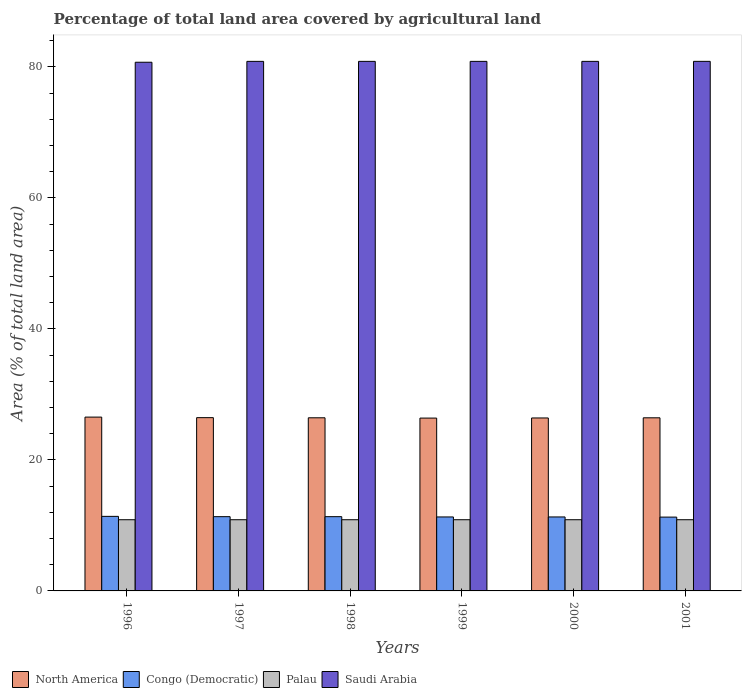How many different coloured bars are there?
Offer a very short reply. 4. How many groups of bars are there?
Provide a succinct answer. 6. How many bars are there on the 2nd tick from the left?
Provide a succinct answer. 4. What is the percentage of agricultural land in Palau in 2001?
Provide a short and direct response. 10.87. Across all years, what is the maximum percentage of agricultural land in Palau?
Give a very brief answer. 10.87. Across all years, what is the minimum percentage of agricultural land in Palau?
Your response must be concise. 10.87. In which year was the percentage of agricultural land in Palau maximum?
Your answer should be very brief. 1996. What is the total percentage of agricultural land in Palau in the graph?
Offer a terse response. 65.22. What is the difference between the percentage of agricultural land in Saudi Arabia in 1996 and that in 1999?
Offer a terse response. -0.13. What is the difference between the percentage of agricultural land in Palau in 2000 and the percentage of agricultural land in Saudi Arabia in 1997?
Provide a succinct answer. -69.97. What is the average percentage of agricultural land in Congo (Democratic) per year?
Offer a terse response. 11.32. In the year 1998, what is the difference between the percentage of agricultural land in Congo (Democratic) and percentage of agricultural land in Saudi Arabia?
Your answer should be very brief. -69.51. In how many years, is the percentage of agricultural land in Saudi Arabia greater than 76 %?
Offer a terse response. 6. What is the ratio of the percentage of agricultural land in Saudi Arabia in 1996 to that in 1999?
Ensure brevity in your answer.  1. What is the difference between the highest and the second highest percentage of agricultural land in Saudi Arabia?
Ensure brevity in your answer.  0. What is the difference between the highest and the lowest percentage of agricultural land in North America?
Offer a terse response. 0.15. In how many years, is the percentage of agricultural land in Congo (Democratic) greater than the average percentage of agricultural land in Congo (Democratic) taken over all years?
Offer a very short reply. 3. What does the 3rd bar from the left in 1999 represents?
Make the answer very short. Palau. What does the 4th bar from the right in 2001 represents?
Ensure brevity in your answer.  North America. How many bars are there?
Make the answer very short. 24. Are all the bars in the graph horizontal?
Keep it short and to the point. No. How many years are there in the graph?
Ensure brevity in your answer.  6. Does the graph contain any zero values?
Your response must be concise. No. What is the title of the graph?
Keep it short and to the point. Percentage of total land area covered by agricultural land. Does "Ukraine" appear as one of the legend labels in the graph?
Ensure brevity in your answer.  No. What is the label or title of the X-axis?
Your response must be concise. Years. What is the label or title of the Y-axis?
Your response must be concise. Area (% of total land area). What is the Area (% of total land area) of North America in 1996?
Ensure brevity in your answer.  26.54. What is the Area (% of total land area) in Congo (Democratic) in 1996?
Offer a very short reply. 11.38. What is the Area (% of total land area) in Palau in 1996?
Keep it short and to the point. 10.87. What is the Area (% of total land area) in Saudi Arabia in 1996?
Your answer should be very brief. 80.71. What is the Area (% of total land area) of North America in 1997?
Provide a succinct answer. 26.45. What is the Area (% of total land area) of Congo (Democratic) in 1997?
Your response must be concise. 11.34. What is the Area (% of total land area) of Palau in 1997?
Offer a very short reply. 10.87. What is the Area (% of total land area) of Saudi Arabia in 1997?
Ensure brevity in your answer.  80.84. What is the Area (% of total land area) of North America in 1998?
Keep it short and to the point. 26.43. What is the Area (% of total land area) in Congo (Democratic) in 1998?
Give a very brief answer. 11.34. What is the Area (% of total land area) in Palau in 1998?
Ensure brevity in your answer.  10.87. What is the Area (% of total land area) in Saudi Arabia in 1998?
Your response must be concise. 80.84. What is the Area (% of total land area) of North America in 1999?
Your response must be concise. 26.39. What is the Area (% of total land area) of Congo (Democratic) in 1999?
Give a very brief answer. 11.29. What is the Area (% of total land area) in Palau in 1999?
Ensure brevity in your answer.  10.87. What is the Area (% of total land area) in Saudi Arabia in 1999?
Your response must be concise. 80.84. What is the Area (% of total land area) in North America in 2000?
Provide a succinct answer. 26.4. What is the Area (% of total land area) of Congo (Democratic) in 2000?
Your answer should be compact. 11.29. What is the Area (% of total land area) in Palau in 2000?
Offer a terse response. 10.87. What is the Area (% of total land area) of Saudi Arabia in 2000?
Offer a very short reply. 80.84. What is the Area (% of total land area) in North America in 2001?
Your answer should be very brief. 26.43. What is the Area (% of total land area) of Congo (Democratic) in 2001?
Ensure brevity in your answer.  11.27. What is the Area (% of total land area) in Palau in 2001?
Offer a very short reply. 10.87. What is the Area (% of total land area) of Saudi Arabia in 2001?
Give a very brief answer. 80.84. Across all years, what is the maximum Area (% of total land area) of North America?
Give a very brief answer. 26.54. Across all years, what is the maximum Area (% of total land area) in Congo (Democratic)?
Give a very brief answer. 11.38. Across all years, what is the maximum Area (% of total land area) in Palau?
Make the answer very short. 10.87. Across all years, what is the maximum Area (% of total land area) of Saudi Arabia?
Give a very brief answer. 80.84. Across all years, what is the minimum Area (% of total land area) of North America?
Make the answer very short. 26.39. Across all years, what is the minimum Area (% of total land area) of Congo (Democratic)?
Make the answer very short. 11.27. Across all years, what is the minimum Area (% of total land area) of Palau?
Your answer should be compact. 10.87. Across all years, what is the minimum Area (% of total land area) in Saudi Arabia?
Your response must be concise. 80.71. What is the total Area (% of total land area) of North America in the graph?
Give a very brief answer. 158.64. What is the total Area (% of total land area) in Congo (Democratic) in the graph?
Ensure brevity in your answer.  67.91. What is the total Area (% of total land area) of Palau in the graph?
Provide a short and direct response. 65.22. What is the total Area (% of total land area) in Saudi Arabia in the graph?
Make the answer very short. 484.92. What is the difference between the Area (% of total land area) in North America in 1996 and that in 1997?
Provide a short and direct response. 0.08. What is the difference between the Area (% of total land area) of Congo (Democratic) in 1996 and that in 1997?
Offer a terse response. 0.04. What is the difference between the Area (% of total land area) in Saudi Arabia in 1996 and that in 1997?
Give a very brief answer. -0.13. What is the difference between the Area (% of total land area) of North America in 1996 and that in 1998?
Your answer should be very brief. 0.11. What is the difference between the Area (% of total land area) of Congo (Democratic) in 1996 and that in 1998?
Offer a terse response. 0.04. What is the difference between the Area (% of total land area) in Saudi Arabia in 1996 and that in 1998?
Ensure brevity in your answer.  -0.13. What is the difference between the Area (% of total land area) of North America in 1996 and that in 1999?
Your answer should be very brief. 0.15. What is the difference between the Area (% of total land area) in Congo (Democratic) in 1996 and that in 1999?
Make the answer very short. 0.09. What is the difference between the Area (% of total land area) of Palau in 1996 and that in 1999?
Make the answer very short. 0. What is the difference between the Area (% of total land area) of Saudi Arabia in 1996 and that in 1999?
Make the answer very short. -0.13. What is the difference between the Area (% of total land area) in North America in 1996 and that in 2000?
Offer a terse response. 0.13. What is the difference between the Area (% of total land area) in Congo (Democratic) in 1996 and that in 2000?
Your response must be concise. 0.09. What is the difference between the Area (% of total land area) of Palau in 1996 and that in 2000?
Your answer should be compact. 0. What is the difference between the Area (% of total land area) in Saudi Arabia in 1996 and that in 2000?
Provide a succinct answer. -0.13. What is the difference between the Area (% of total land area) in North America in 1996 and that in 2001?
Offer a terse response. 0.11. What is the difference between the Area (% of total land area) of Congo (Democratic) in 1996 and that in 2001?
Ensure brevity in your answer.  0.11. What is the difference between the Area (% of total land area) of Palau in 1996 and that in 2001?
Your response must be concise. 0. What is the difference between the Area (% of total land area) in Saudi Arabia in 1996 and that in 2001?
Your answer should be very brief. -0.14. What is the difference between the Area (% of total land area) of North America in 1997 and that in 1998?
Ensure brevity in your answer.  0.02. What is the difference between the Area (% of total land area) in North America in 1997 and that in 1999?
Offer a very short reply. 0.07. What is the difference between the Area (% of total land area) of Congo (Democratic) in 1997 and that in 1999?
Offer a very short reply. 0.04. What is the difference between the Area (% of total land area) of Palau in 1997 and that in 1999?
Provide a short and direct response. 0. What is the difference between the Area (% of total land area) of North America in 1997 and that in 2000?
Provide a succinct answer. 0.05. What is the difference between the Area (% of total land area) in Congo (Democratic) in 1997 and that in 2000?
Your response must be concise. 0.04. What is the difference between the Area (% of total land area) of Saudi Arabia in 1997 and that in 2000?
Your answer should be compact. 0. What is the difference between the Area (% of total land area) of North America in 1997 and that in 2001?
Your answer should be very brief. 0.03. What is the difference between the Area (% of total land area) of Congo (Democratic) in 1997 and that in 2001?
Your answer should be compact. 0.07. What is the difference between the Area (% of total land area) in Palau in 1997 and that in 2001?
Offer a very short reply. 0. What is the difference between the Area (% of total land area) in Saudi Arabia in 1997 and that in 2001?
Your response must be concise. -0. What is the difference between the Area (% of total land area) in North America in 1998 and that in 1999?
Your answer should be compact. 0.04. What is the difference between the Area (% of total land area) in Congo (Democratic) in 1998 and that in 1999?
Your answer should be very brief. 0.04. What is the difference between the Area (% of total land area) in Palau in 1998 and that in 1999?
Give a very brief answer. 0. What is the difference between the Area (% of total land area) of Saudi Arabia in 1998 and that in 1999?
Offer a very short reply. 0. What is the difference between the Area (% of total land area) in North America in 1998 and that in 2000?
Provide a succinct answer. 0.03. What is the difference between the Area (% of total land area) of Congo (Democratic) in 1998 and that in 2000?
Keep it short and to the point. 0.04. What is the difference between the Area (% of total land area) in Saudi Arabia in 1998 and that in 2000?
Give a very brief answer. 0. What is the difference between the Area (% of total land area) of North America in 1998 and that in 2001?
Ensure brevity in your answer.  0. What is the difference between the Area (% of total land area) of Congo (Democratic) in 1998 and that in 2001?
Provide a succinct answer. 0.07. What is the difference between the Area (% of total land area) in Saudi Arabia in 1998 and that in 2001?
Offer a very short reply. -0. What is the difference between the Area (% of total land area) in North America in 1999 and that in 2000?
Your answer should be very brief. -0.02. What is the difference between the Area (% of total land area) in Saudi Arabia in 1999 and that in 2000?
Offer a very short reply. 0. What is the difference between the Area (% of total land area) in North America in 1999 and that in 2001?
Give a very brief answer. -0.04. What is the difference between the Area (% of total land area) of Congo (Democratic) in 1999 and that in 2001?
Offer a very short reply. 0.02. What is the difference between the Area (% of total land area) in Saudi Arabia in 1999 and that in 2001?
Your answer should be compact. -0. What is the difference between the Area (% of total land area) in North America in 2000 and that in 2001?
Ensure brevity in your answer.  -0.02. What is the difference between the Area (% of total land area) of Congo (Democratic) in 2000 and that in 2001?
Ensure brevity in your answer.  0.02. What is the difference between the Area (% of total land area) of Palau in 2000 and that in 2001?
Make the answer very short. 0. What is the difference between the Area (% of total land area) of Saudi Arabia in 2000 and that in 2001?
Offer a terse response. -0. What is the difference between the Area (% of total land area) of North America in 1996 and the Area (% of total land area) of Congo (Democratic) in 1997?
Provide a succinct answer. 15.2. What is the difference between the Area (% of total land area) of North America in 1996 and the Area (% of total land area) of Palau in 1997?
Provide a succinct answer. 15.67. What is the difference between the Area (% of total land area) in North America in 1996 and the Area (% of total land area) in Saudi Arabia in 1997?
Keep it short and to the point. -54.31. What is the difference between the Area (% of total land area) of Congo (Democratic) in 1996 and the Area (% of total land area) of Palau in 1997?
Your answer should be very brief. 0.51. What is the difference between the Area (% of total land area) in Congo (Democratic) in 1996 and the Area (% of total land area) in Saudi Arabia in 1997?
Provide a succinct answer. -69.46. What is the difference between the Area (% of total land area) in Palau in 1996 and the Area (% of total land area) in Saudi Arabia in 1997?
Offer a very short reply. -69.97. What is the difference between the Area (% of total land area) of North America in 1996 and the Area (% of total land area) of Congo (Democratic) in 1998?
Ensure brevity in your answer.  15.2. What is the difference between the Area (% of total land area) of North America in 1996 and the Area (% of total land area) of Palau in 1998?
Make the answer very short. 15.67. What is the difference between the Area (% of total land area) of North America in 1996 and the Area (% of total land area) of Saudi Arabia in 1998?
Give a very brief answer. -54.31. What is the difference between the Area (% of total land area) in Congo (Democratic) in 1996 and the Area (% of total land area) in Palau in 1998?
Keep it short and to the point. 0.51. What is the difference between the Area (% of total land area) in Congo (Democratic) in 1996 and the Area (% of total land area) in Saudi Arabia in 1998?
Ensure brevity in your answer.  -69.46. What is the difference between the Area (% of total land area) in Palau in 1996 and the Area (% of total land area) in Saudi Arabia in 1998?
Keep it short and to the point. -69.97. What is the difference between the Area (% of total land area) of North America in 1996 and the Area (% of total land area) of Congo (Democratic) in 1999?
Give a very brief answer. 15.24. What is the difference between the Area (% of total land area) of North America in 1996 and the Area (% of total land area) of Palau in 1999?
Your response must be concise. 15.67. What is the difference between the Area (% of total land area) of North America in 1996 and the Area (% of total land area) of Saudi Arabia in 1999?
Ensure brevity in your answer.  -54.31. What is the difference between the Area (% of total land area) of Congo (Democratic) in 1996 and the Area (% of total land area) of Palau in 1999?
Offer a terse response. 0.51. What is the difference between the Area (% of total land area) in Congo (Democratic) in 1996 and the Area (% of total land area) in Saudi Arabia in 1999?
Your answer should be very brief. -69.46. What is the difference between the Area (% of total land area) of Palau in 1996 and the Area (% of total land area) of Saudi Arabia in 1999?
Offer a terse response. -69.97. What is the difference between the Area (% of total land area) in North America in 1996 and the Area (% of total land area) in Congo (Democratic) in 2000?
Give a very brief answer. 15.24. What is the difference between the Area (% of total land area) in North America in 1996 and the Area (% of total land area) in Palau in 2000?
Offer a terse response. 15.67. What is the difference between the Area (% of total land area) in North America in 1996 and the Area (% of total land area) in Saudi Arabia in 2000?
Your answer should be very brief. -54.31. What is the difference between the Area (% of total land area) of Congo (Democratic) in 1996 and the Area (% of total land area) of Palau in 2000?
Offer a very short reply. 0.51. What is the difference between the Area (% of total land area) in Congo (Democratic) in 1996 and the Area (% of total land area) in Saudi Arabia in 2000?
Offer a terse response. -69.46. What is the difference between the Area (% of total land area) in Palau in 1996 and the Area (% of total land area) in Saudi Arabia in 2000?
Keep it short and to the point. -69.97. What is the difference between the Area (% of total land area) in North America in 1996 and the Area (% of total land area) in Congo (Democratic) in 2001?
Offer a terse response. 15.27. What is the difference between the Area (% of total land area) in North America in 1996 and the Area (% of total land area) in Palau in 2001?
Ensure brevity in your answer.  15.67. What is the difference between the Area (% of total land area) of North America in 1996 and the Area (% of total land area) of Saudi Arabia in 2001?
Offer a terse response. -54.31. What is the difference between the Area (% of total land area) in Congo (Democratic) in 1996 and the Area (% of total land area) in Palau in 2001?
Provide a short and direct response. 0.51. What is the difference between the Area (% of total land area) of Congo (Democratic) in 1996 and the Area (% of total land area) of Saudi Arabia in 2001?
Provide a succinct answer. -69.46. What is the difference between the Area (% of total land area) of Palau in 1996 and the Area (% of total land area) of Saudi Arabia in 2001?
Provide a succinct answer. -69.98. What is the difference between the Area (% of total land area) in North America in 1997 and the Area (% of total land area) in Congo (Democratic) in 1998?
Keep it short and to the point. 15.12. What is the difference between the Area (% of total land area) in North America in 1997 and the Area (% of total land area) in Palau in 1998?
Offer a very short reply. 15.58. What is the difference between the Area (% of total land area) in North America in 1997 and the Area (% of total land area) in Saudi Arabia in 1998?
Your answer should be very brief. -54.39. What is the difference between the Area (% of total land area) of Congo (Democratic) in 1997 and the Area (% of total land area) of Palau in 1998?
Offer a very short reply. 0.47. What is the difference between the Area (% of total land area) of Congo (Democratic) in 1997 and the Area (% of total land area) of Saudi Arabia in 1998?
Your response must be concise. -69.51. What is the difference between the Area (% of total land area) in Palau in 1997 and the Area (% of total land area) in Saudi Arabia in 1998?
Provide a succinct answer. -69.97. What is the difference between the Area (% of total land area) in North America in 1997 and the Area (% of total land area) in Congo (Democratic) in 1999?
Provide a short and direct response. 15.16. What is the difference between the Area (% of total land area) of North America in 1997 and the Area (% of total land area) of Palau in 1999?
Provide a succinct answer. 15.58. What is the difference between the Area (% of total land area) in North America in 1997 and the Area (% of total land area) in Saudi Arabia in 1999?
Give a very brief answer. -54.39. What is the difference between the Area (% of total land area) in Congo (Democratic) in 1997 and the Area (% of total land area) in Palau in 1999?
Provide a short and direct response. 0.47. What is the difference between the Area (% of total land area) of Congo (Democratic) in 1997 and the Area (% of total land area) of Saudi Arabia in 1999?
Offer a terse response. -69.51. What is the difference between the Area (% of total land area) of Palau in 1997 and the Area (% of total land area) of Saudi Arabia in 1999?
Make the answer very short. -69.97. What is the difference between the Area (% of total land area) in North America in 1997 and the Area (% of total land area) in Congo (Democratic) in 2000?
Make the answer very short. 15.16. What is the difference between the Area (% of total land area) of North America in 1997 and the Area (% of total land area) of Palau in 2000?
Give a very brief answer. 15.58. What is the difference between the Area (% of total land area) in North America in 1997 and the Area (% of total land area) in Saudi Arabia in 2000?
Keep it short and to the point. -54.39. What is the difference between the Area (% of total land area) of Congo (Democratic) in 1997 and the Area (% of total land area) of Palau in 2000?
Make the answer very short. 0.47. What is the difference between the Area (% of total land area) in Congo (Democratic) in 1997 and the Area (% of total land area) in Saudi Arabia in 2000?
Give a very brief answer. -69.51. What is the difference between the Area (% of total land area) in Palau in 1997 and the Area (% of total land area) in Saudi Arabia in 2000?
Provide a short and direct response. -69.97. What is the difference between the Area (% of total land area) in North America in 1997 and the Area (% of total land area) in Congo (Democratic) in 2001?
Offer a terse response. 15.18. What is the difference between the Area (% of total land area) in North America in 1997 and the Area (% of total land area) in Palau in 2001?
Ensure brevity in your answer.  15.58. What is the difference between the Area (% of total land area) of North America in 1997 and the Area (% of total land area) of Saudi Arabia in 2001?
Offer a terse response. -54.39. What is the difference between the Area (% of total land area) of Congo (Democratic) in 1997 and the Area (% of total land area) of Palau in 2001?
Make the answer very short. 0.47. What is the difference between the Area (% of total land area) in Congo (Democratic) in 1997 and the Area (% of total land area) in Saudi Arabia in 2001?
Give a very brief answer. -69.51. What is the difference between the Area (% of total land area) in Palau in 1997 and the Area (% of total land area) in Saudi Arabia in 2001?
Your answer should be compact. -69.98. What is the difference between the Area (% of total land area) of North America in 1998 and the Area (% of total land area) of Congo (Democratic) in 1999?
Your answer should be very brief. 15.14. What is the difference between the Area (% of total land area) of North America in 1998 and the Area (% of total land area) of Palau in 1999?
Provide a succinct answer. 15.56. What is the difference between the Area (% of total land area) in North America in 1998 and the Area (% of total land area) in Saudi Arabia in 1999?
Your answer should be compact. -54.41. What is the difference between the Area (% of total land area) in Congo (Democratic) in 1998 and the Area (% of total land area) in Palau in 1999?
Keep it short and to the point. 0.47. What is the difference between the Area (% of total land area) in Congo (Democratic) in 1998 and the Area (% of total land area) in Saudi Arabia in 1999?
Give a very brief answer. -69.51. What is the difference between the Area (% of total land area) of Palau in 1998 and the Area (% of total land area) of Saudi Arabia in 1999?
Provide a succinct answer. -69.97. What is the difference between the Area (% of total land area) of North America in 1998 and the Area (% of total land area) of Congo (Democratic) in 2000?
Your answer should be very brief. 15.14. What is the difference between the Area (% of total land area) of North America in 1998 and the Area (% of total land area) of Palau in 2000?
Offer a very short reply. 15.56. What is the difference between the Area (% of total land area) of North America in 1998 and the Area (% of total land area) of Saudi Arabia in 2000?
Keep it short and to the point. -54.41. What is the difference between the Area (% of total land area) of Congo (Democratic) in 1998 and the Area (% of total land area) of Palau in 2000?
Provide a short and direct response. 0.47. What is the difference between the Area (% of total land area) of Congo (Democratic) in 1998 and the Area (% of total land area) of Saudi Arabia in 2000?
Offer a terse response. -69.51. What is the difference between the Area (% of total land area) in Palau in 1998 and the Area (% of total land area) in Saudi Arabia in 2000?
Ensure brevity in your answer.  -69.97. What is the difference between the Area (% of total land area) in North America in 1998 and the Area (% of total land area) in Congo (Democratic) in 2001?
Keep it short and to the point. 15.16. What is the difference between the Area (% of total land area) of North America in 1998 and the Area (% of total land area) of Palau in 2001?
Ensure brevity in your answer.  15.56. What is the difference between the Area (% of total land area) of North America in 1998 and the Area (% of total land area) of Saudi Arabia in 2001?
Give a very brief answer. -54.41. What is the difference between the Area (% of total land area) of Congo (Democratic) in 1998 and the Area (% of total land area) of Palau in 2001?
Make the answer very short. 0.47. What is the difference between the Area (% of total land area) in Congo (Democratic) in 1998 and the Area (% of total land area) in Saudi Arabia in 2001?
Your answer should be compact. -69.51. What is the difference between the Area (% of total land area) in Palau in 1998 and the Area (% of total land area) in Saudi Arabia in 2001?
Make the answer very short. -69.98. What is the difference between the Area (% of total land area) of North America in 1999 and the Area (% of total land area) of Congo (Democratic) in 2000?
Give a very brief answer. 15.09. What is the difference between the Area (% of total land area) in North America in 1999 and the Area (% of total land area) in Palau in 2000?
Keep it short and to the point. 15.52. What is the difference between the Area (% of total land area) of North America in 1999 and the Area (% of total land area) of Saudi Arabia in 2000?
Make the answer very short. -54.46. What is the difference between the Area (% of total land area) in Congo (Democratic) in 1999 and the Area (% of total land area) in Palau in 2000?
Offer a terse response. 0.42. What is the difference between the Area (% of total land area) of Congo (Democratic) in 1999 and the Area (% of total land area) of Saudi Arabia in 2000?
Offer a very short reply. -69.55. What is the difference between the Area (% of total land area) of Palau in 1999 and the Area (% of total land area) of Saudi Arabia in 2000?
Your answer should be compact. -69.97. What is the difference between the Area (% of total land area) of North America in 1999 and the Area (% of total land area) of Congo (Democratic) in 2001?
Keep it short and to the point. 15.12. What is the difference between the Area (% of total land area) of North America in 1999 and the Area (% of total land area) of Palau in 2001?
Your answer should be very brief. 15.52. What is the difference between the Area (% of total land area) in North America in 1999 and the Area (% of total land area) in Saudi Arabia in 2001?
Ensure brevity in your answer.  -54.46. What is the difference between the Area (% of total land area) in Congo (Democratic) in 1999 and the Area (% of total land area) in Palau in 2001?
Provide a succinct answer. 0.42. What is the difference between the Area (% of total land area) of Congo (Democratic) in 1999 and the Area (% of total land area) of Saudi Arabia in 2001?
Provide a short and direct response. -69.55. What is the difference between the Area (% of total land area) of Palau in 1999 and the Area (% of total land area) of Saudi Arabia in 2001?
Ensure brevity in your answer.  -69.98. What is the difference between the Area (% of total land area) of North America in 2000 and the Area (% of total land area) of Congo (Democratic) in 2001?
Your response must be concise. 15.13. What is the difference between the Area (% of total land area) in North America in 2000 and the Area (% of total land area) in Palau in 2001?
Keep it short and to the point. 15.53. What is the difference between the Area (% of total land area) in North America in 2000 and the Area (% of total land area) in Saudi Arabia in 2001?
Provide a short and direct response. -54.44. What is the difference between the Area (% of total land area) in Congo (Democratic) in 2000 and the Area (% of total land area) in Palau in 2001?
Offer a terse response. 0.42. What is the difference between the Area (% of total land area) in Congo (Democratic) in 2000 and the Area (% of total land area) in Saudi Arabia in 2001?
Offer a very short reply. -69.55. What is the difference between the Area (% of total land area) in Palau in 2000 and the Area (% of total land area) in Saudi Arabia in 2001?
Ensure brevity in your answer.  -69.98. What is the average Area (% of total land area) of North America per year?
Make the answer very short. 26.44. What is the average Area (% of total land area) of Congo (Democratic) per year?
Offer a terse response. 11.32. What is the average Area (% of total land area) of Palau per year?
Your response must be concise. 10.87. What is the average Area (% of total land area) in Saudi Arabia per year?
Provide a short and direct response. 80.82. In the year 1996, what is the difference between the Area (% of total land area) of North America and Area (% of total land area) of Congo (Democratic)?
Your answer should be compact. 15.16. In the year 1996, what is the difference between the Area (% of total land area) of North America and Area (% of total land area) of Palau?
Ensure brevity in your answer.  15.67. In the year 1996, what is the difference between the Area (% of total land area) of North America and Area (% of total land area) of Saudi Arabia?
Provide a short and direct response. -54.17. In the year 1996, what is the difference between the Area (% of total land area) in Congo (Democratic) and Area (% of total land area) in Palau?
Make the answer very short. 0.51. In the year 1996, what is the difference between the Area (% of total land area) in Congo (Democratic) and Area (% of total land area) in Saudi Arabia?
Provide a succinct answer. -69.33. In the year 1996, what is the difference between the Area (% of total land area) of Palau and Area (% of total land area) of Saudi Arabia?
Offer a very short reply. -69.84. In the year 1997, what is the difference between the Area (% of total land area) in North America and Area (% of total land area) in Congo (Democratic)?
Give a very brief answer. 15.12. In the year 1997, what is the difference between the Area (% of total land area) in North America and Area (% of total land area) in Palau?
Offer a terse response. 15.58. In the year 1997, what is the difference between the Area (% of total land area) in North America and Area (% of total land area) in Saudi Arabia?
Offer a very short reply. -54.39. In the year 1997, what is the difference between the Area (% of total land area) in Congo (Democratic) and Area (% of total land area) in Palau?
Make the answer very short. 0.47. In the year 1997, what is the difference between the Area (% of total land area) in Congo (Democratic) and Area (% of total land area) in Saudi Arabia?
Your answer should be compact. -69.51. In the year 1997, what is the difference between the Area (% of total land area) of Palau and Area (% of total land area) of Saudi Arabia?
Give a very brief answer. -69.97. In the year 1998, what is the difference between the Area (% of total land area) in North America and Area (% of total land area) in Congo (Democratic)?
Your answer should be very brief. 15.09. In the year 1998, what is the difference between the Area (% of total land area) in North America and Area (% of total land area) in Palau?
Keep it short and to the point. 15.56. In the year 1998, what is the difference between the Area (% of total land area) of North America and Area (% of total land area) of Saudi Arabia?
Ensure brevity in your answer.  -54.41. In the year 1998, what is the difference between the Area (% of total land area) of Congo (Democratic) and Area (% of total land area) of Palau?
Make the answer very short. 0.47. In the year 1998, what is the difference between the Area (% of total land area) in Congo (Democratic) and Area (% of total land area) in Saudi Arabia?
Provide a short and direct response. -69.51. In the year 1998, what is the difference between the Area (% of total land area) of Palau and Area (% of total land area) of Saudi Arabia?
Your answer should be very brief. -69.97. In the year 1999, what is the difference between the Area (% of total land area) of North America and Area (% of total land area) of Congo (Democratic)?
Your answer should be very brief. 15.09. In the year 1999, what is the difference between the Area (% of total land area) in North America and Area (% of total land area) in Palau?
Offer a very short reply. 15.52. In the year 1999, what is the difference between the Area (% of total land area) of North America and Area (% of total land area) of Saudi Arabia?
Offer a very short reply. -54.46. In the year 1999, what is the difference between the Area (% of total land area) of Congo (Democratic) and Area (% of total land area) of Palau?
Your answer should be very brief. 0.42. In the year 1999, what is the difference between the Area (% of total land area) in Congo (Democratic) and Area (% of total land area) in Saudi Arabia?
Ensure brevity in your answer.  -69.55. In the year 1999, what is the difference between the Area (% of total land area) of Palau and Area (% of total land area) of Saudi Arabia?
Give a very brief answer. -69.97. In the year 2000, what is the difference between the Area (% of total land area) in North America and Area (% of total land area) in Congo (Democratic)?
Offer a very short reply. 15.11. In the year 2000, what is the difference between the Area (% of total land area) in North America and Area (% of total land area) in Palau?
Give a very brief answer. 15.53. In the year 2000, what is the difference between the Area (% of total land area) in North America and Area (% of total land area) in Saudi Arabia?
Make the answer very short. -54.44. In the year 2000, what is the difference between the Area (% of total land area) of Congo (Democratic) and Area (% of total land area) of Palau?
Ensure brevity in your answer.  0.42. In the year 2000, what is the difference between the Area (% of total land area) in Congo (Democratic) and Area (% of total land area) in Saudi Arabia?
Offer a very short reply. -69.55. In the year 2000, what is the difference between the Area (% of total land area) in Palau and Area (% of total land area) in Saudi Arabia?
Keep it short and to the point. -69.97. In the year 2001, what is the difference between the Area (% of total land area) of North America and Area (% of total land area) of Congo (Democratic)?
Keep it short and to the point. 15.16. In the year 2001, what is the difference between the Area (% of total land area) in North America and Area (% of total land area) in Palau?
Your answer should be very brief. 15.56. In the year 2001, what is the difference between the Area (% of total land area) of North America and Area (% of total land area) of Saudi Arabia?
Provide a short and direct response. -54.42. In the year 2001, what is the difference between the Area (% of total land area) in Congo (Democratic) and Area (% of total land area) in Palau?
Provide a short and direct response. 0.4. In the year 2001, what is the difference between the Area (% of total land area) of Congo (Democratic) and Area (% of total land area) of Saudi Arabia?
Your answer should be very brief. -69.57. In the year 2001, what is the difference between the Area (% of total land area) of Palau and Area (% of total land area) of Saudi Arabia?
Your response must be concise. -69.98. What is the ratio of the Area (% of total land area) of Saudi Arabia in 1996 to that in 1997?
Offer a terse response. 1. What is the ratio of the Area (% of total land area) of Congo (Democratic) in 1996 to that in 1998?
Give a very brief answer. 1. What is the ratio of the Area (% of total land area) of Saudi Arabia in 1996 to that in 1998?
Ensure brevity in your answer.  1. What is the ratio of the Area (% of total land area) of North America in 1996 to that in 2000?
Ensure brevity in your answer.  1. What is the ratio of the Area (% of total land area) in Palau in 1996 to that in 2000?
Your response must be concise. 1. What is the ratio of the Area (% of total land area) in Congo (Democratic) in 1996 to that in 2001?
Keep it short and to the point. 1.01. What is the ratio of the Area (% of total land area) of Palau in 1996 to that in 2001?
Give a very brief answer. 1. What is the ratio of the Area (% of total land area) of Saudi Arabia in 1996 to that in 2001?
Keep it short and to the point. 1. What is the ratio of the Area (% of total land area) in North America in 1997 to that in 1998?
Give a very brief answer. 1. What is the ratio of the Area (% of total land area) in North America in 1997 to that in 1999?
Your response must be concise. 1. What is the ratio of the Area (% of total land area) in Congo (Democratic) in 1997 to that in 1999?
Your response must be concise. 1. What is the ratio of the Area (% of total land area) in Palau in 1997 to that in 1999?
Your answer should be very brief. 1. What is the ratio of the Area (% of total land area) in North America in 1997 to that in 2000?
Ensure brevity in your answer.  1. What is the ratio of the Area (% of total land area) in Congo (Democratic) in 1997 to that in 2000?
Your response must be concise. 1. What is the ratio of the Area (% of total land area) of Palau in 1997 to that in 2000?
Offer a terse response. 1. What is the ratio of the Area (% of total land area) of Saudi Arabia in 1997 to that in 2000?
Give a very brief answer. 1. What is the ratio of the Area (% of total land area) of North America in 1997 to that in 2001?
Your answer should be very brief. 1. What is the ratio of the Area (% of total land area) of Congo (Democratic) in 1997 to that in 2001?
Your response must be concise. 1.01. What is the ratio of the Area (% of total land area) in Saudi Arabia in 1997 to that in 2001?
Make the answer very short. 1. What is the ratio of the Area (% of total land area) of North America in 1998 to that in 1999?
Your answer should be compact. 1. What is the ratio of the Area (% of total land area) in Palau in 1998 to that in 1999?
Give a very brief answer. 1. What is the ratio of the Area (% of total land area) in Saudi Arabia in 1998 to that in 1999?
Keep it short and to the point. 1. What is the ratio of the Area (% of total land area) in Congo (Democratic) in 1998 to that in 2000?
Your response must be concise. 1. What is the ratio of the Area (% of total land area) in Palau in 1998 to that in 2000?
Give a very brief answer. 1. What is the ratio of the Area (% of total land area) in Saudi Arabia in 1998 to that in 2000?
Keep it short and to the point. 1. What is the ratio of the Area (% of total land area) of Congo (Democratic) in 1998 to that in 2001?
Offer a very short reply. 1.01. What is the ratio of the Area (% of total land area) of Palau in 1999 to that in 2000?
Provide a succinct answer. 1. What is the ratio of the Area (% of total land area) in Congo (Democratic) in 1999 to that in 2001?
Keep it short and to the point. 1. What is the ratio of the Area (% of total land area) in Palau in 1999 to that in 2001?
Give a very brief answer. 1. What is the ratio of the Area (% of total land area) of Congo (Democratic) in 2000 to that in 2001?
Ensure brevity in your answer.  1. What is the ratio of the Area (% of total land area) of Palau in 2000 to that in 2001?
Ensure brevity in your answer.  1. What is the difference between the highest and the second highest Area (% of total land area) of North America?
Make the answer very short. 0.08. What is the difference between the highest and the second highest Area (% of total land area) of Congo (Democratic)?
Provide a short and direct response. 0.04. What is the difference between the highest and the second highest Area (% of total land area) in Saudi Arabia?
Provide a short and direct response. 0. What is the difference between the highest and the lowest Area (% of total land area) in North America?
Your answer should be compact. 0.15. What is the difference between the highest and the lowest Area (% of total land area) in Congo (Democratic)?
Your response must be concise. 0.11. What is the difference between the highest and the lowest Area (% of total land area) of Saudi Arabia?
Offer a terse response. 0.14. 